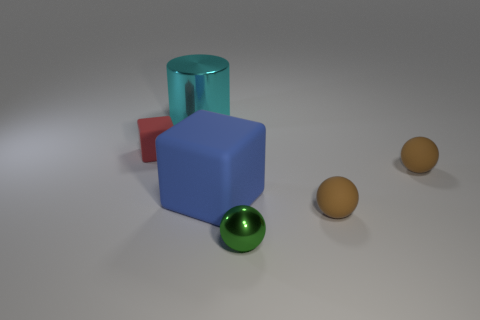There is a large shiny cylinder; are there any large rubber things in front of it?
Offer a terse response. Yes. How many things are small red matte objects that are left of the blue rubber block or large brown balls?
Provide a succinct answer. 1. What is the size of the red cube that is the same material as the blue thing?
Offer a terse response. Small. There is a red object; is it the same size as the metal thing that is behind the blue matte thing?
Offer a very short reply. No. There is a thing that is both in front of the large matte object and behind the shiny ball; what color is it?
Your answer should be very brief. Brown. How many objects are either metal things to the right of the big cyan object or balls that are right of the green sphere?
Your response must be concise. 3. The metallic object behind the metal sphere that is to the right of the tiny matte object that is to the left of the large cyan cylinder is what color?
Provide a short and direct response. Cyan. Is there a small brown thing that has the same shape as the green shiny object?
Provide a succinct answer. Yes. What number of small green matte things are there?
Your answer should be very brief. 0. The large rubber thing has what shape?
Make the answer very short. Cube. 